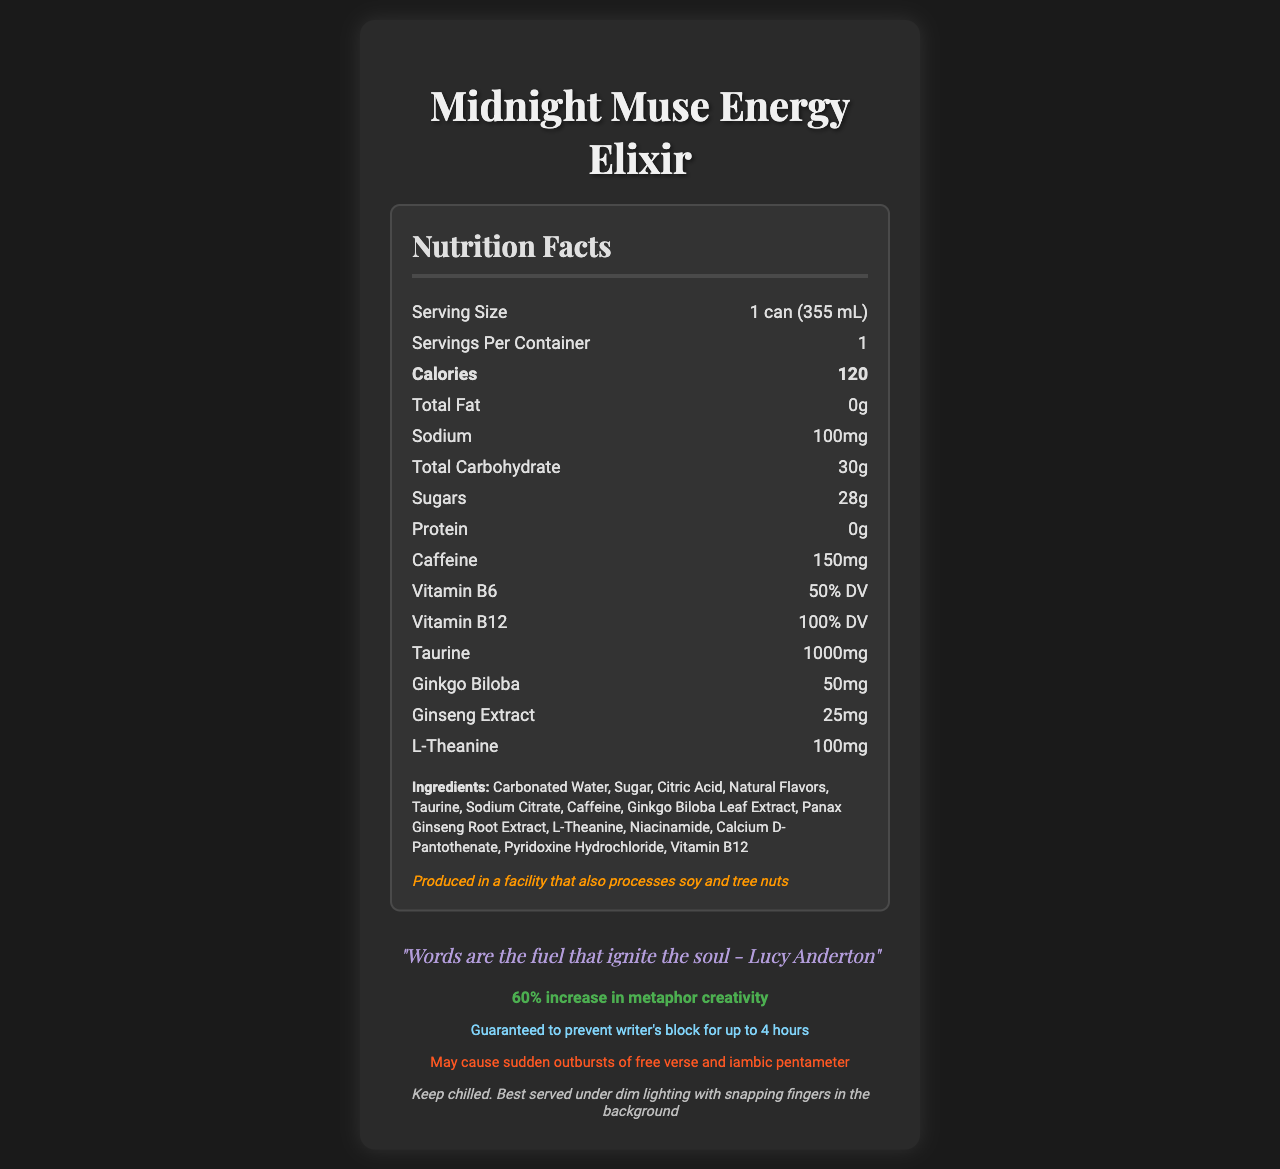what is the serving size? The document states the serving size is 1 can (355 mL).
Answer: 1 can (355 mL) how many calories are in one serving? The document lists 120 calories under the nutrition facts.
Answer: 120 what are the main ingredients? The ingredients are stated in the ingredients section of the document.
Answer: Carbonated Water, Sugar, Citric Acid, Natural Flavors, Taurine, Sodium Citrate, Caffeine, Ginkgo Biloba Leaf Extract, Panax Ginseng Root Extract, L-Theanine, Niacinamide, Calcium D-Pantothenate, Pyridoxine Hydrochloride, Vitamin B12 how much sodium is in one serving? The document lists 100mg of sodium under the nutrition facts.
Answer: 100mg what percentage of daily value for Vitamin B6 does this drink provide? The document shows 50% DV for Vitamin B6.
Answer: 50% DV which vitamin has a higher percentage of daily value in this drink? A. Vitamin B6 B. Vitamin B12 C. Vitamin D The document states Vitamin B12 is 100% DV, which is higher than Vitamin B6 at 50% DV, and Vitamin D is not listed.
Answer: B what is the caffeine content per serving? The document lists 150mg of caffeine in the nutrition facts.
Answer: 150mg what is the product name? The document's title and header mention "Midnight Muse Energy Elixir."
Answer: Midnight Muse Energy Elixir does the drink contain any protein? The document states 0g of protein.
Answer: No what is the artistic warning given on the document? The artistic warning is found in a highlighted section at the bottom of the document.
Answer: May cause sudden outbursts of free verse and iambic pentameter what is the single most inspiring quote included in the document? The quote by Lucy Anderton is prominently displayed and highlighted in the document.
Answer: "Words are the fuel that ignite the soul - Lucy Anderton" how should the drink be stored? A. At room temperature B. In a freezer C. Chilled The storage instructions say to "Keep chilled."
Answer: C will this energy drink help with writer's block? The document includes a "wordsmith warranty" that guarantees to prevent writer's block for up to 4 hours.
Answer: Yes does the document mention if it is safe for people with nut allergies? The allergen information states the product is produced in a facility that processes soy and tree nuts.
Answer: Produced in a facility that also processes soy and tree nuts how much taurine is in one serving? The document lists 1000mg of taurine under the nutrition facts.
Answer: 1000mg what kind of performance boost is claimed by this drink? The document claims the drink provides a 60% increase in metaphor creativity.
Answer: 60% increase in metaphor creativity summarize the main purpose and contents of the document. The document focuses on providing comprehensive nutritional information for an energy drink designed to boost performance during poetry slams, alongside motivational and safety notes.
Answer: The document is a detailed Nutrition Facts Label for "Midnight Muse Energy Elixir," an energy drink. It includes nutritional information such as calories, vitamins, and specific ingredients beneficial for late-night poetry slams. The document also highlights inspirational quotes, potential performance benefits, artistic warnings, and storage instructions. The label notes the drink’s ability to prevent writer's block and its allergen information. what is the background color of the document? The color scheme is not detailed in the text information provided, making it impossible to determine from the description alone.
Answer: Not enough information 